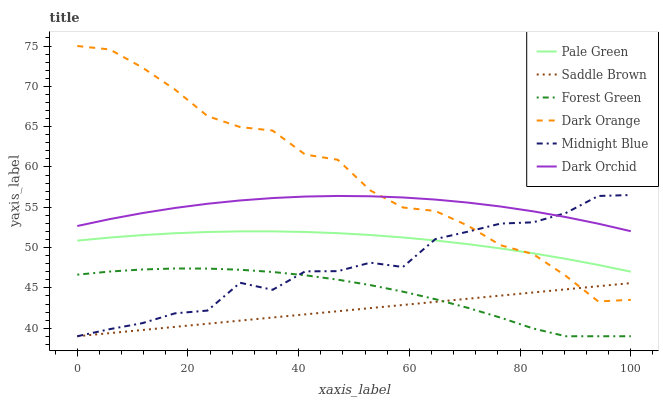Does Saddle Brown have the minimum area under the curve?
Answer yes or no. Yes. Does Dark Orange have the maximum area under the curve?
Answer yes or no. Yes. Does Midnight Blue have the minimum area under the curve?
Answer yes or no. No. Does Midnight Blue have the maximum area under the curve?
Answer yes or no. No. Is Saddle Brown the smoothest?
Answer yes or no. Yes. Is Midnight Blue the roughest?
Answer yes or no. Yes. Is Dark Orchid the smoothest?
Answer yes or no. No. Is Dark Orchid the roughest?
Answer yes or no. No. Does Midnight Blue have the lowest value?
Answer yes or no. Yes. Does Dark Orchid have the lowest value?
Answer yes or no. No. Does Dark Orange have the highest value?
Answer yes or no. Yes. Does Midnight Blue have the highest value?
Answer yes or no. No. Is Forest Green less than Dark Orchid?
Answer yes or no. Yes. Is Dark Orchid greater than Saddle Brown?
Answer yes or no. Yes. Does Saddle Brown intersect Dark Orange?
Answer yes or no. Yes. Is Saddle Brown less than Dark Orange?
Answer yes or no. No. Is Saddle Brown greater than Dark Orange?
Answer yes or no. No. Does Forest Green intersect Dark Orchid?
Answer yes or no. No. 